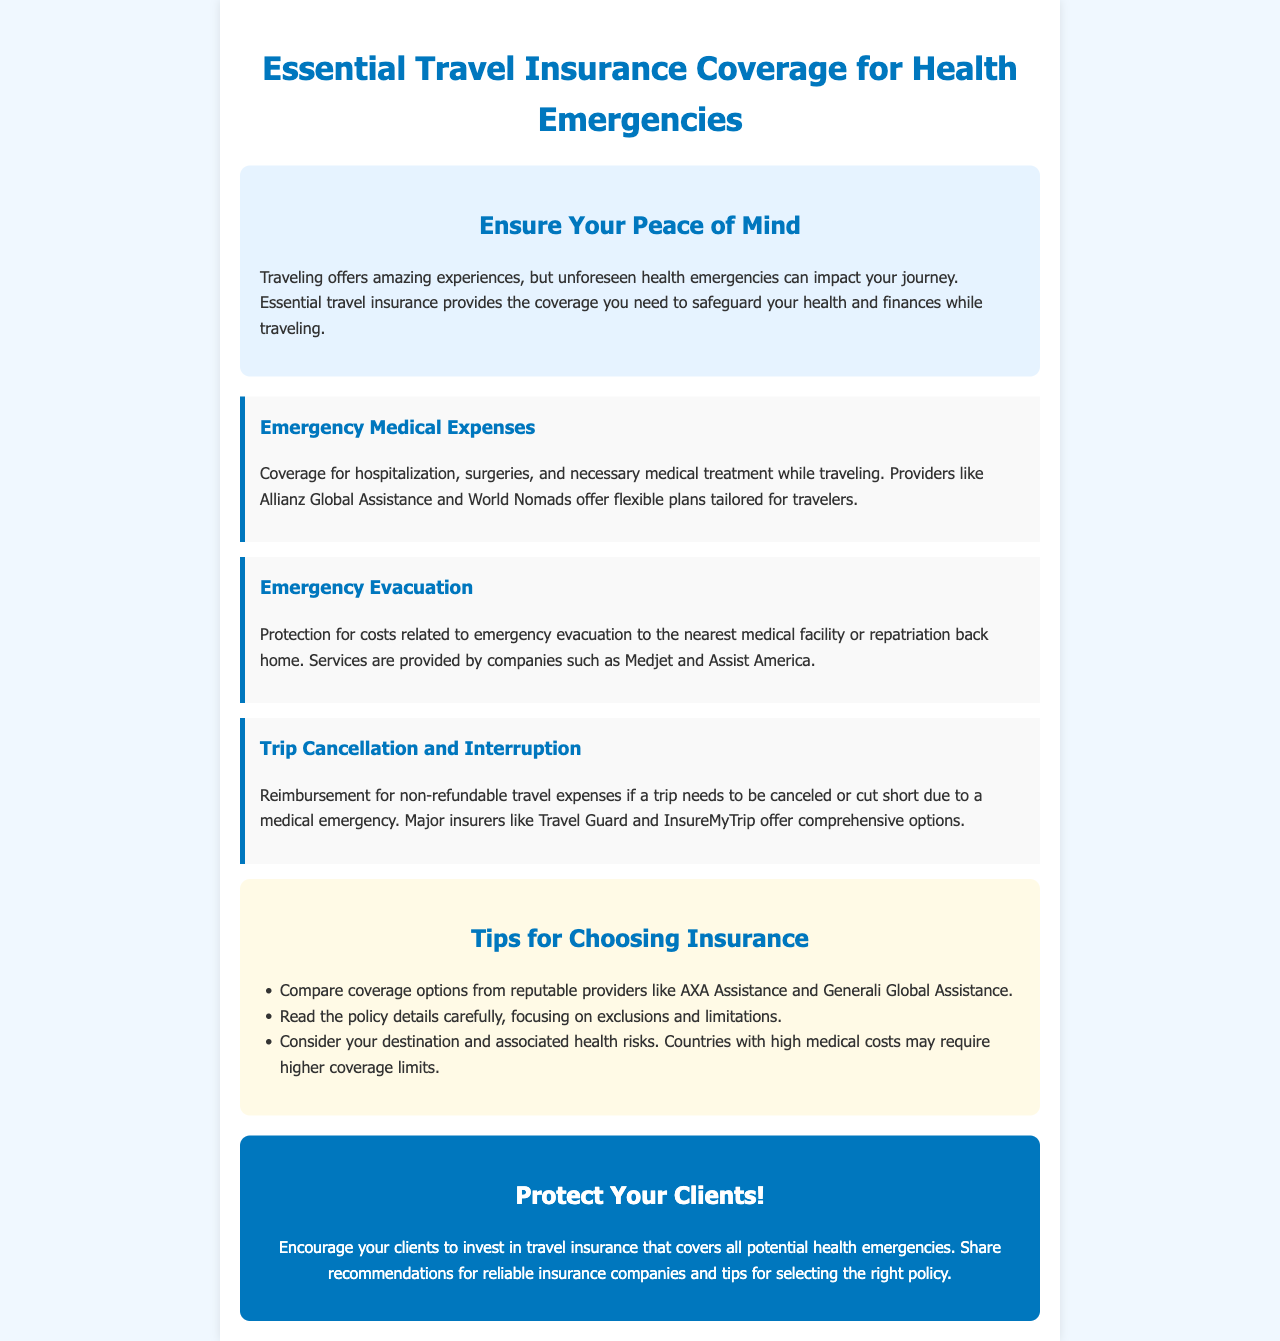What is the title of the brochure? The title is presented prominently at the top of the document.
Answer: Essential Travel Insurance Coverage for Health Emergencies What type of expenses does the insurance cover? The document lists various coverage types including medical expenses.
Answer: Emergency Medical Expenses Which companies provide emergency evacuation services? The document mentions specific companies for emergency evacuation.
Answer: Medjet and Assist America What should clients do if they need to cancel a trip due to a medical emergency? The document explains reimbursement options for trip cancellations related to health issues.
Answer: Reimbursement for non-refundable travel expenses Name one tip for choosing insurance. A specific tip is provided in the document for selecting an insurance provider.
Answer: Compare coverage options from reputable providers How does high medical costs affect insurance coverage? The reasoning about destination and health risks relates to insurance needs.
Answer: Higher coverage limits may be required What background color is used for the intro section? The introductory section's background color is specified in the document's design.
Answer: Light blue What does the "Protect Your Clients!" section emphasize? This section highlights the importance of an action related to travel insurance.
Answer: Investing in travel insurance Which companies offer Emergency Medical Expenses coverage? The document lists providers for emergency medical expenses.
Answer: Allianz Global Assistance and World Nomads 